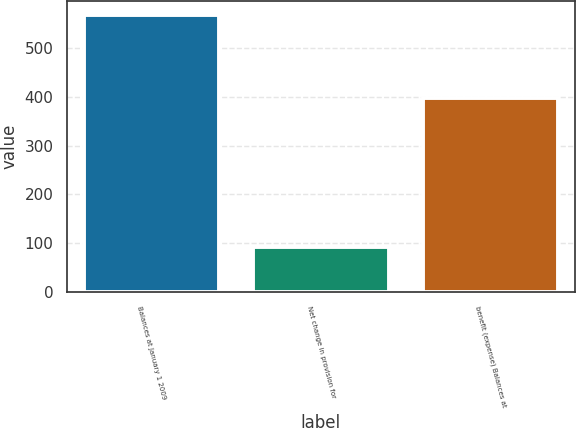Convert chart to OTSL. <chart><loc_0><loc_0><loc_500><loc_500><bar_chart><fcel>Balances at January 1 2009<fcel>Net change in provision for<fcel>benefit (expense) Balances at<nl><fcel>567.3<fcel>92.2<fcel>396.2<nl></chart> 